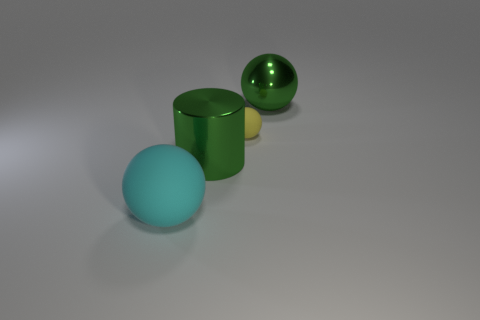There is a ball that is the same color as the shiny cylinder; what is its size?
Offer a terse response. Large. How many things are both in front of the large green sphere and behind the big cyan sphere?
Your answer should be compact. 2. What is the large sphere that is left of the tiny rubber object made of?
Offer a terse response. Rubber. The yellow ball that is made of the same material as the big cyan sphere is what size?
Offer a very short reply. Small. There is a shiny ball; are there any large green things right of it?
Provide a succinct answer. No. There is a yellow object that is the same shape as the large cyan rubber thing; what is its size?
Provide a short and direct response. Small. There is a big metal sphere; is its color the same as the metallic object that is left of the small yellow sphere?
Offer a terse response. Yes. Does the big shiny cylinder have the same color as the large metal ball?
Give a very brief answer. Yes. Are there fewer matte spheres than objects?
Ensure brevity in your answer.  Yes. What number of other things are there of the same color as the tiny thing?
Offer a very short reply. 0. 